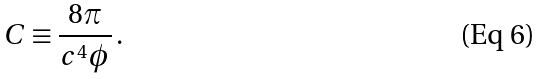Convert formula to latex. <formula><loc_0><loc_0><loc_500><loc_500>C \equiv \frac { 8 \pi } { c ^ { 4 } \phi } \, .</formula> 